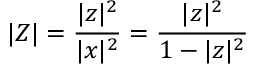<formula> <loc_0><loc_0><loc_500><loc_500>| Z | = { \frac { | z | ^ { 2 } } { | x | ^ { 2 } } } = { \frac { | z | ^ { 2 } } { 1 - | z | ^ { 2 } } }</formula> 